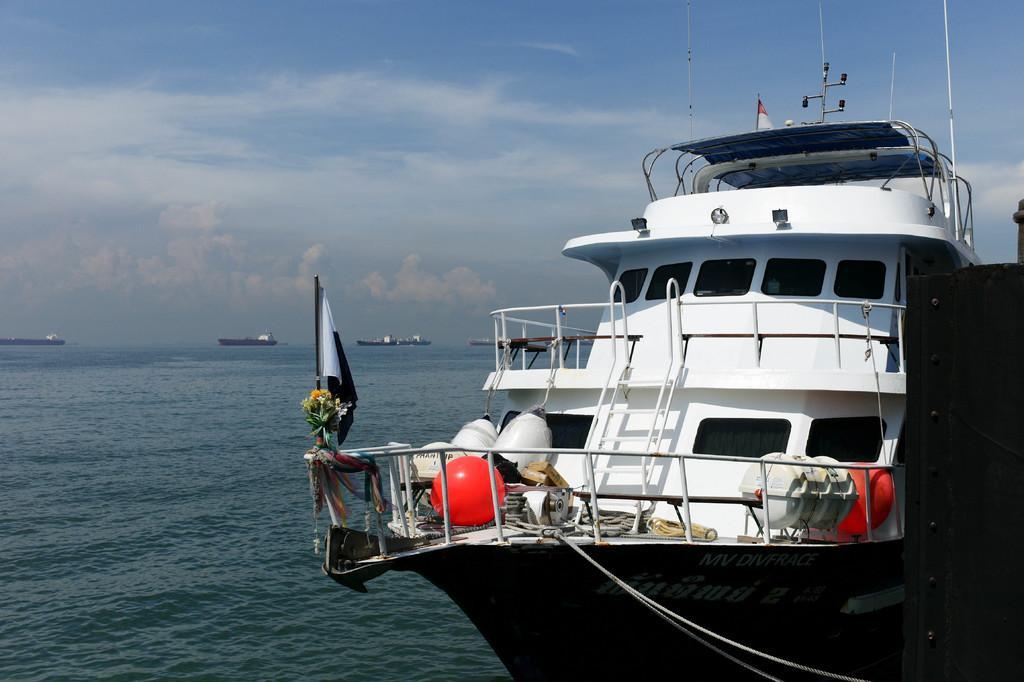In one or two sentences, can you explain what this image depicts? In the foreground of the image we can see a boat with staircase, flags, some objects, balls, flowers and ribbons is placed in water. In the background, we can see some ships and the cloudy sky. 